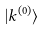Convert formula to latex. <formula><loc_0><loc_0><loc_500><loc_500>| k ^ { ( 0 ) } \rangle</formula> 